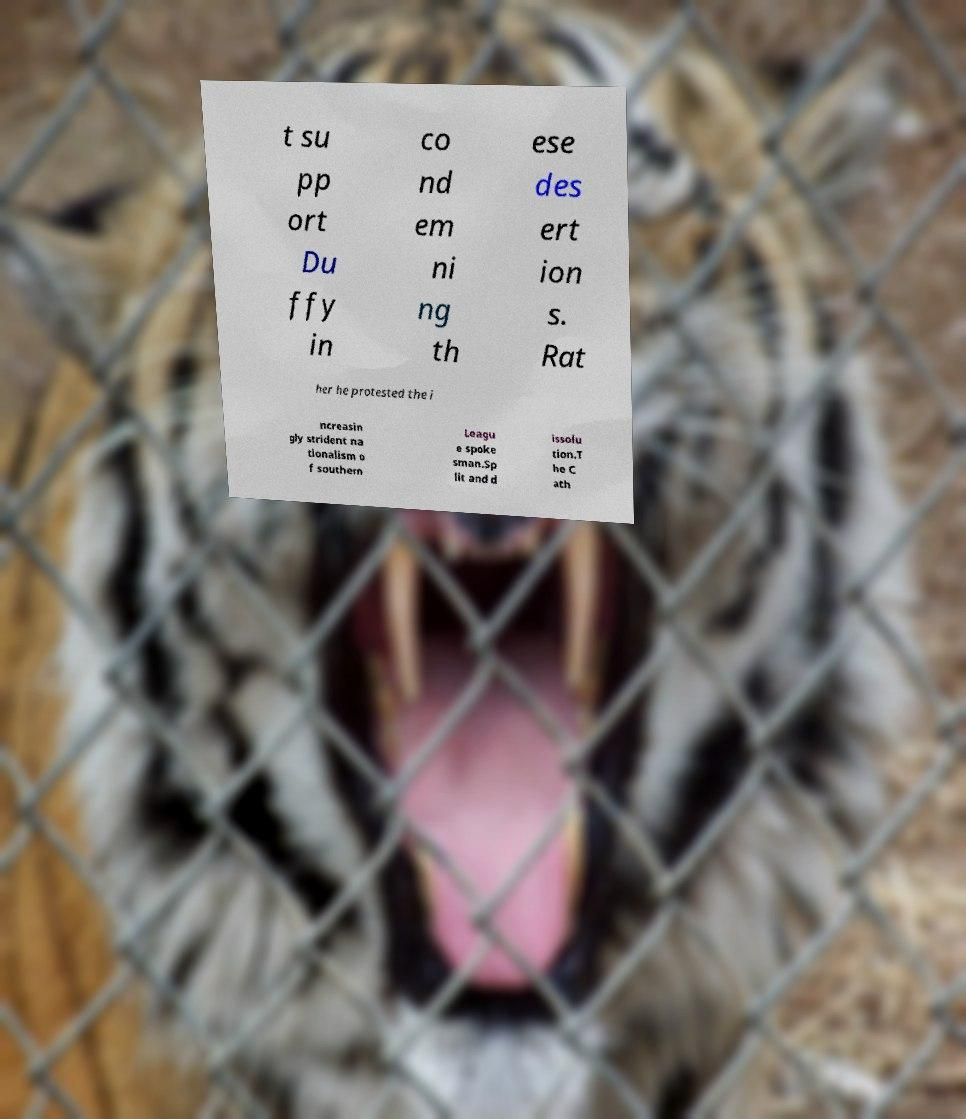Could you extract and type out the text from this image? t su pp ort Du ffy in co nd em ni ng th ese des ert ion s. Rat her he protested the i ncreasin gly strident na tionalism o f southern Leagu e spoke sman.Sp lit and d issolu tion.T he C ath 